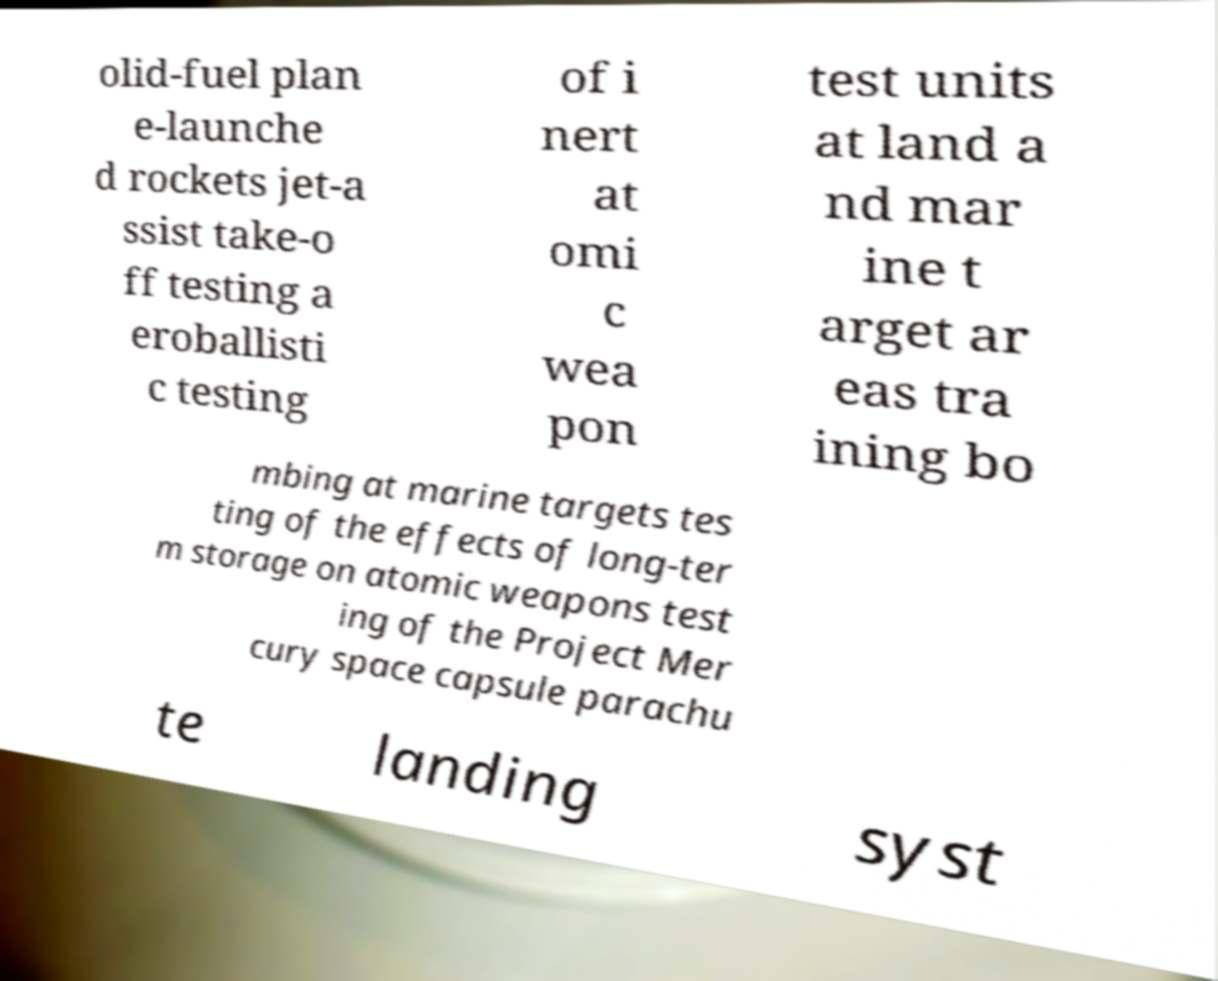Please read and relay the text visible in this image. What does it say? olid-fuel plan e-launche d rockets jet-a ssist take-o ff testing a eroballisti c testing of i nert at omi c wea pon test units at land a nd mar ine t arget ar eas tra ining bo mbing at marine targets tes ting of the effects of long-ter m storage on atomic weapons test ing of the Project Mer cury space capsule parachu te landing syst 